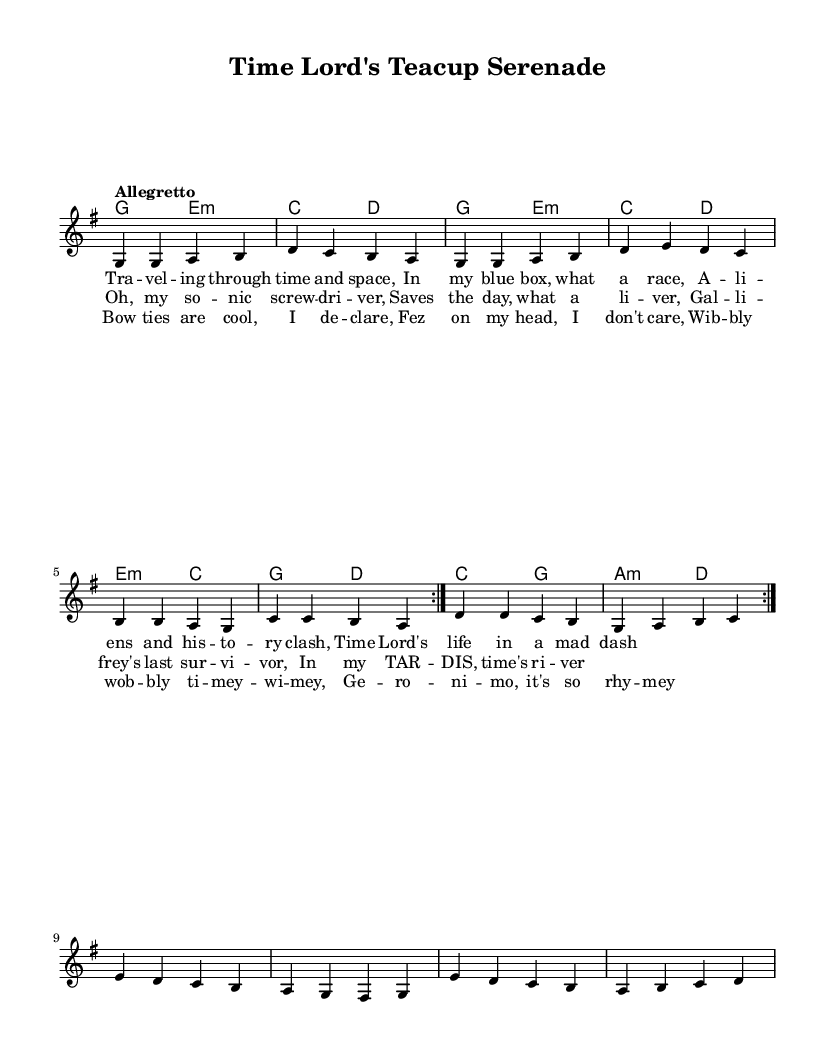What is the key signature of this music? The key signature is indicated at the beginning of the score, showing one sharp, which corresponds to the key of G major.
Answer: G major What is the time signature of this music? The time signature is displayed at the beginning of the score, specifically as 4/4, which means there are four beats in every measure.
Answer: 4/4 What is the tempo marking for this piece? The tempo marking is found near the beginning and states "Allegretto," indicating a moderately brisk tempo.
Answer: Allegretto How many times is the melody repeated in the first section? By examining the repeat signs in the melody section, we can see that it indicates two repetitions of the melody.
Answer: 2 What are the last two words of the bridge section? The lyrics are provided in the bridge, and the last two words can be found at the end of the bridge lyrical line, which are "so rhyme-y."
Answer: so rhyme-y What is a unique instrument mentioned in the lyrics? By reviewing the lyrics, particularly in the chorus, the "sonic screwdriver" is referenced as a unique and unconventional instrument.
Answer: sonic screwdriver What phrase captures the quirky essence of this song? Analyzing the lyrics across the song reveals the phrase "Bow ties are cool," which embodies the quirky British pop theme of the piece.
Answer: Bow ties are cool 